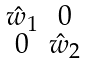Convert formula to latex. <formula><loc_0><loc_0><loc_500><loc_500>\begin{smallmatrix} \hat { w } _ { 1 } & 0 \\ 0 & \hat { w } _ { 2 } \end{smallmatrix}</formula> 